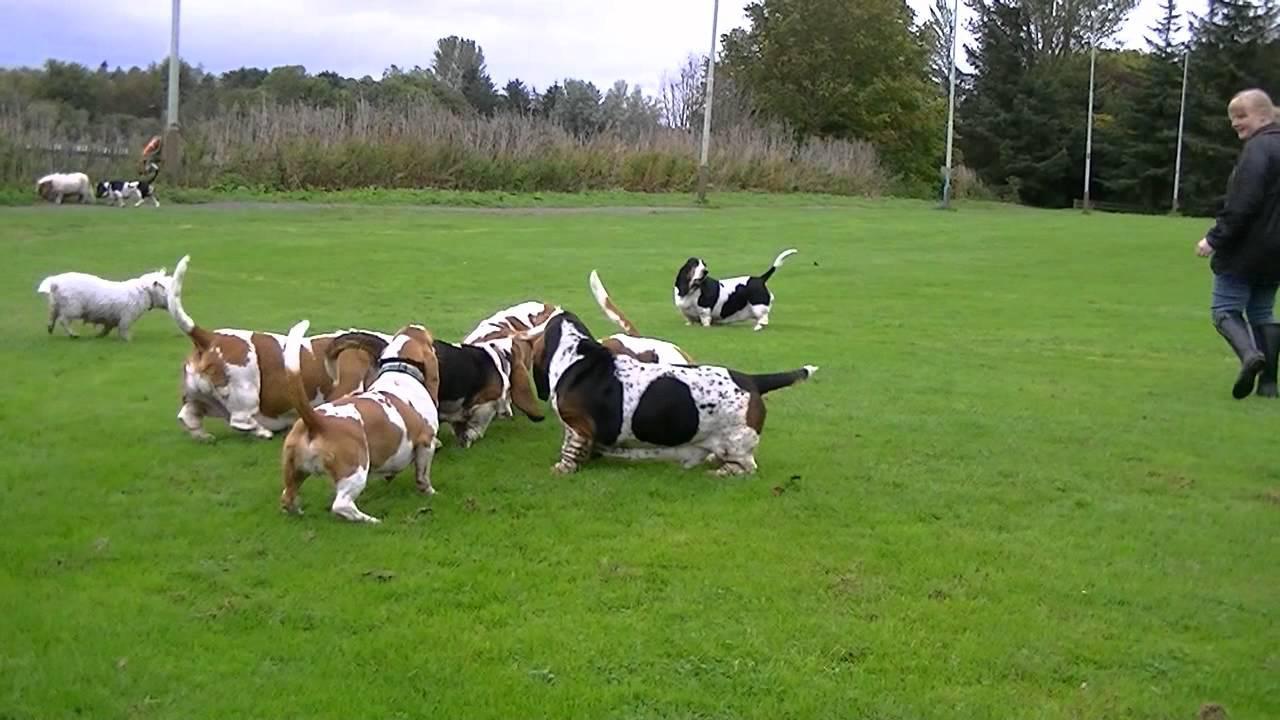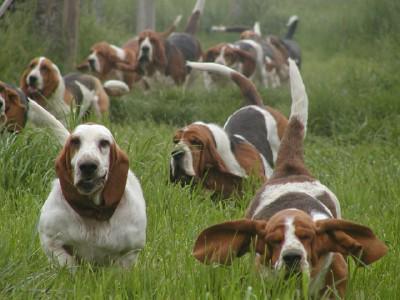The first image is the image on the left, the second image is the image on the right. Given the left and right images, does the statement "One of the images shows at least one dog on a leash." hold true? Answer yes or no. No. The first image is the image on the left, the second image is the image on the right. Assess this claim about the two images: "One image shows just one beagle, with no leash attached.". Correct or not? Answer yes or no. No. 